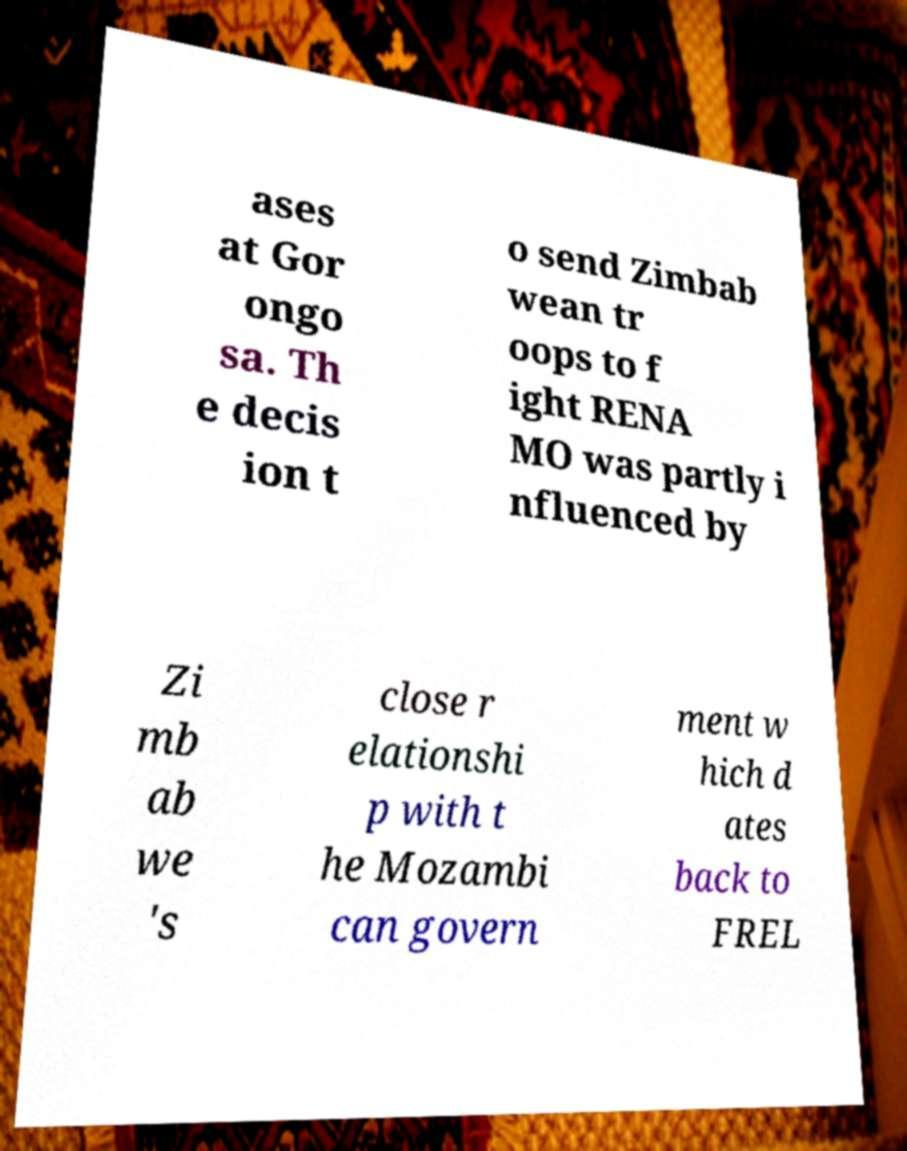What messages or text are displayed in this image? I need them in a readable, typed format. ases at Gor ongo sa. Th e decis ion t o send Zimbab wean tr oops to f ight RENA MO was partly i nfluenced by Zi mb ab we 's close r elationshi p with t he Mozambi can govern ment w hich d ates back to FREL 